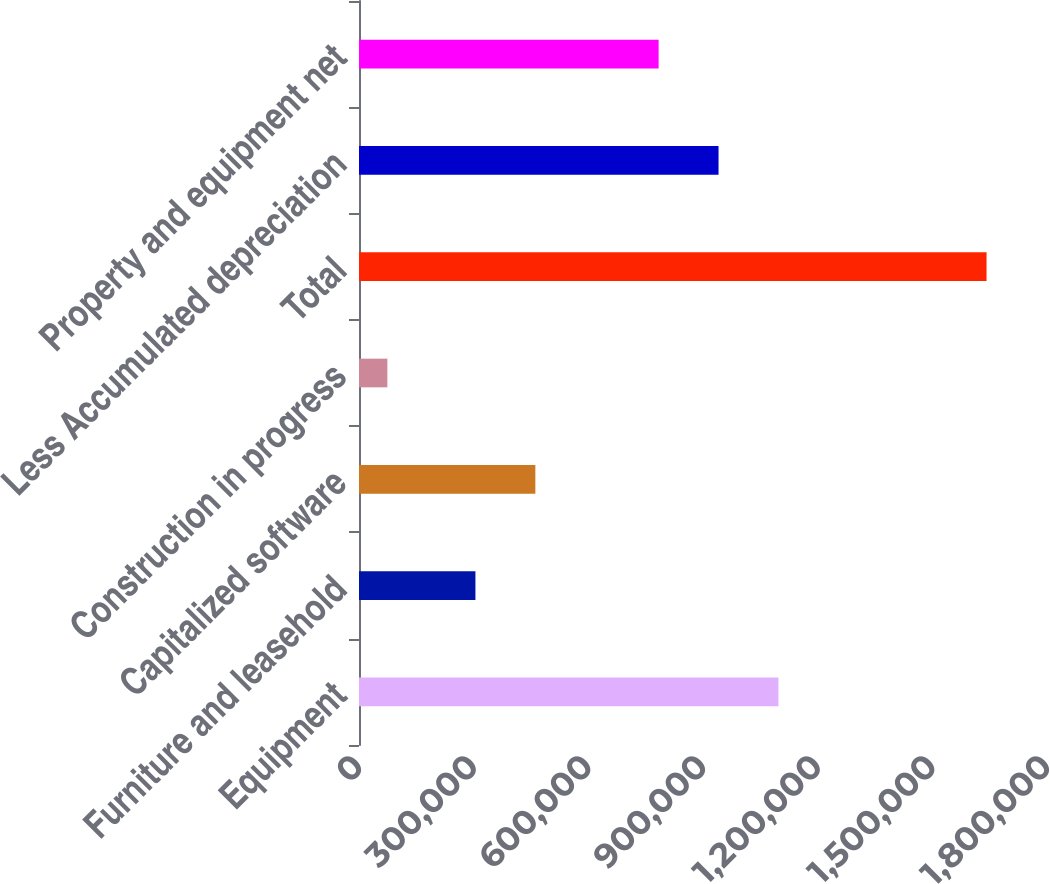<chart> <loc_0><loc_0><loc_500><loc_500><bar_chart><fcel>Equipment<fcel>Furniture and leasehold<fcel>Capitalized software<fcel>Construction in progress<fcel>Total<fcel>Less Accumulated depreciation<fcel>Property and equipment net<nl><fcel>1.09742e+06<fcel>304613<fcel>461370<fcel>74255<fcel>1.64183e+06<fcel>940658<fcel>783901<nl></chart> 